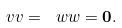Convert formula to latex. <formula><loc_0><loc_0><loc_500><loc_500>\ v v = \ w w = { \mathbf 0 } .</formula> 